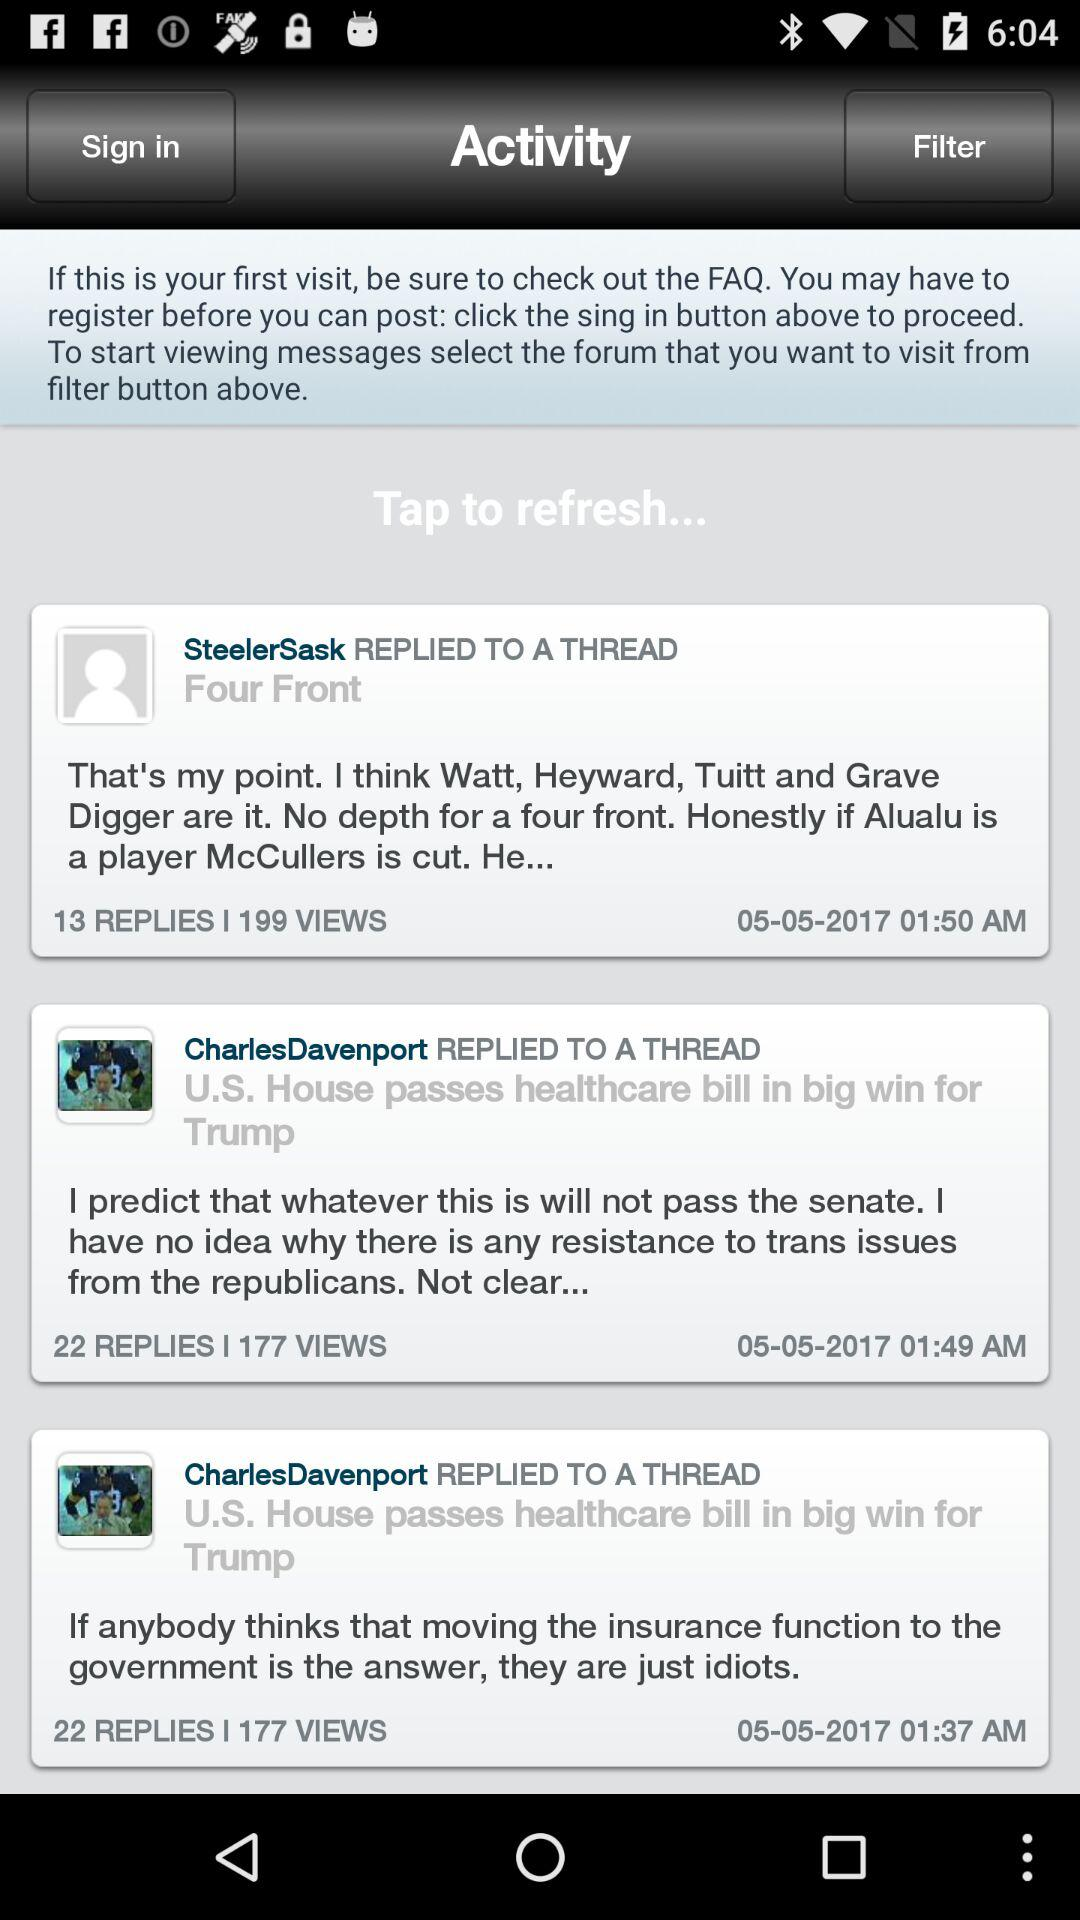How many more replies does the third most recent post have than the first?
Answer the question using a single word or phrase. 9 